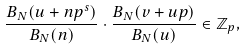Convert formula to latex. <formula><loc_0><loc_0><loc_500><loc_500>\frac { B _ { N } ( u + n p ^ { s } ) } { B _ { N } ( n ) } \cdot \frac { B _ { N } ( v + u p ) } { B _ { N } ( u ) } \in \mathbb { Z } _ { p } ,</formula> 